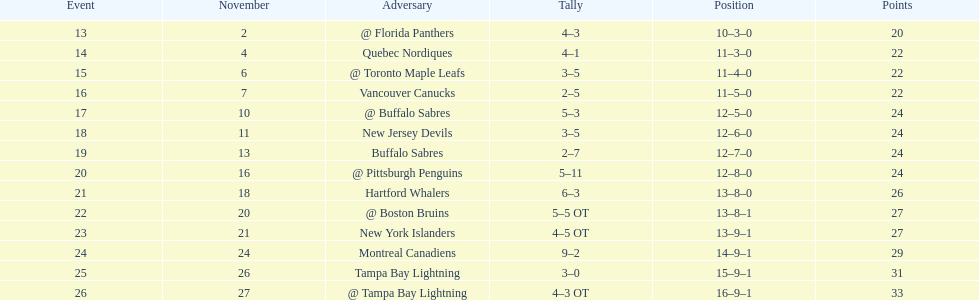The 1993-1994 flyers missed the playoffs again. how many consecutive seasons up until 93-94 did the flyers miss the playoffs? 5. 